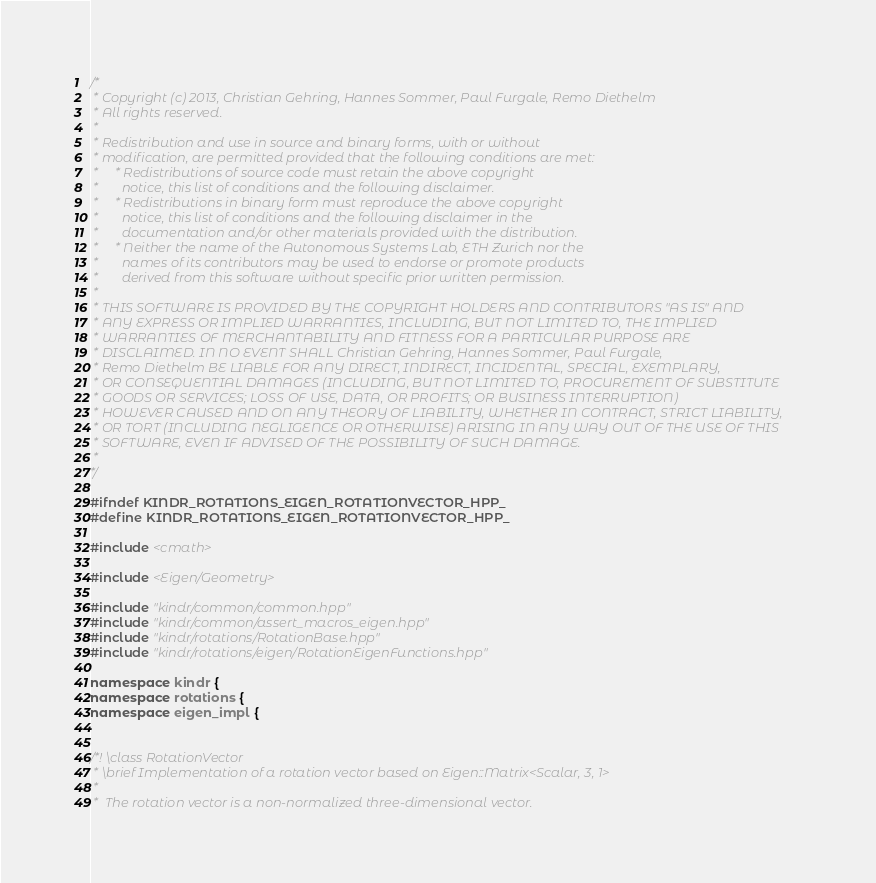Convert code to text. <code><loc_0><loc_0><loc_500><loc_500><_C++_>/*
 * Copyright (c) 2013, Christian Gehring, Hannes Sommer, Paul Furgale, Remo Diethelm
 * All rights reserved.
 *
 * Redistribution and use in source and binary forms, with or without
 * modification, are permitted provided that the following conditions are met:
 *     * Redistributions of source code must retain the above copyright
 *       notice, this list of conditions and the following disclaimer.
 *     * Redistributions in binary form must reproduce the above copyright
 *       notice, this list of conditions and the following disclaimer in the
 *       documentation and/or other materials provided with the distribution.
 *     * Neither the name of the Autonomous Systems Lab, ETH Zurich nor the
 *       names of its contributors may be used to endorse or promote products
 *       derived from this software without specific prior written permission.
 *
 * THIS SOFTWARE IS PROVIDED BY THE COPYRIGHT HOLDERS AND CONTRIBUTORS "AS IS" AND
 * ANY EXPRESS OR IMPLIED WARRANTIES, INCLUDING, BUT NOT LIMITED TO, THE IMPLIED
 * WARRANTIES OF MERCHANTABILITY AND FITNESS FOR A PARTICULAR PURPOSE ARE
 * DISCLAIMED. IN NO EVENT SHALL Christian Gehring, Hannes Sommer, Paul Furgale,
 * Remo Diethelm BE LIABLE FOR ANY DIRECT, INDIRECT, INCIDENTAL, SPECIAL, EXEMPLARY,
 * OR CONSEQUENTIAL DAMAGES (INCLUDING, BUT NOT LIMITED TO, PROCUREMENT OF SUBSTITUTE
 * GOODS OR SERVICES; LOSS OF USE, DATA, OR PROFITS; OR BUSINESS INTERRUPTION)
 * HOWEVER CAUSED AND ON ANY THEORY OF LIABILITY, WHETHER IN CONTRACT, STRICT LIABILITY,
 * OR TORT (INCLUDING NEGLIGENCE OR OTHERWISE) ARISING IN ANY WAY OUT OF THE USE OF THIS
 * SOFTWARE, EVEN IF ADVISED OF THE POSSIBILITY OF SUCH DAMAGE.
 *
*/

#ifndef KINDR_ROTATIONS_EIGEN_ROTATIONVECTOR_HPP_
#define KINDR_ROTATIONS_EIGEN_ROTATIONVECTOR_HPP_

#include <cmath>

#include <Eigen/Geometry>

#include "kindr/common/common.hpp"
#include "kindr/common/assert_macros_eigen.hpp"
#include "kindr/rotations/RotationBase.hpp"
#include "kindr/rotations/eigen/RotationEigenFunctions.hpp"

namespace kindr {
namespace rotations {
namespace eigen_impl {


/*! \class RotationVector
 * \brief Implementation of a rotation vector based on Eigen::Matrix<Scalar, 3, 1>
 *
 *  The rotation vector is a non-normalized three-dimensional vector.</code> 